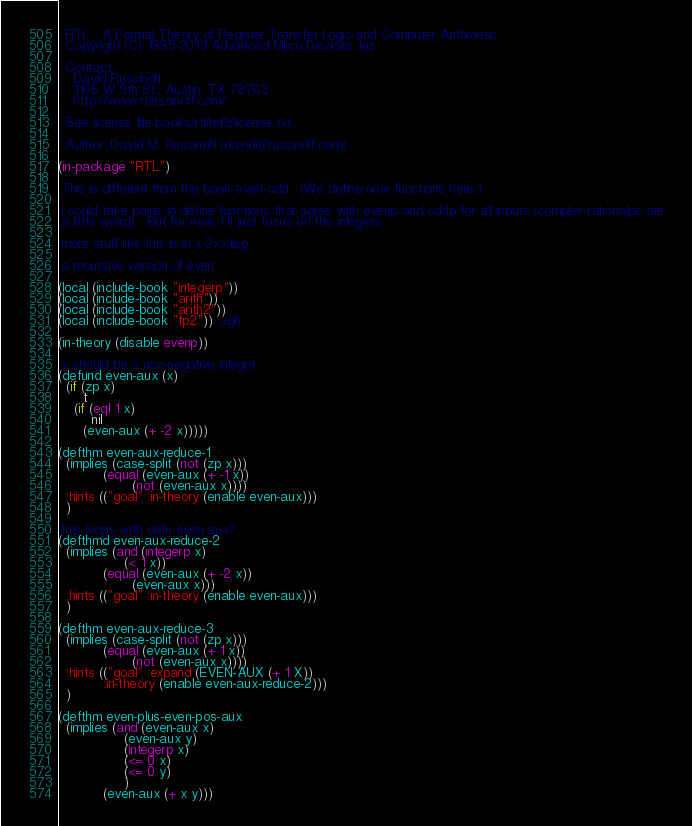Convert code to text. <code><loc_0><loc_0><loc_500><loc_500><_Lisp_>; RTL - A Formal Theory of Register-Transfer Logic and Computer Arithmetic
; Copyright (C) 1995-2013 Advanced Mirco Devices, Inc.
;
; Contact:
;   David Russinoff
;   1106 W 9th St., Austin, TX 78703
;   http://www.russsinoff.com/
;
; See license file books/rtl/rel9/license.txt.
;
; Author: David M. Russinoff (david@russinoff.com)

(in-package "RTL")

;This is different from the book even-odd.  (We define new functions here.)

;I could take pains to define functions that agree with evenp and oddp for all inputs (complex-rationalps are
;a little weird).  But for now, I'll just focus on the integers.

;more stuff like this is in x-2xx.lisp

;a recursive version of even

(local (include-book "integerp"))
(local (include-book "arith"))
(local (include-book "arith2"))
(local (include-book "fp2")) ;ugh

(in-theory (disable evenp))

;x should be a non-negative integer
(defund even-aux (x)
  (if (zp x)
      t
    (if (eql 1 x)
        nil
      (even-aux (+ -2 x)))))

(defthm even-aux-reduce-1
  (implies (case-split (not (zp x)))
           (equal (even-aux (+ -1 x))
                  (not (even-aux x))))
  :hints (("goal" :in-theory (enable even-aux)))
  )

;this loops with defn even-aux?
(defthmd even-aux-reduce-2
  (implies (and (integerp x)
                (< 1 x))
           (equal (even-aux (+ -2 x))
                  (even-aux x)))
  :hints (("goal" :in-theory (enable even-aux)))
  )

(defthm even-aux-reduce-3
  (implies (case-split (not (zp x)))
           (equal (even-aux (+ 1 x))
                  (not (even-aux x))))
  :hints (("goal" :expand (EVEN-AUX (+ 1 X))
           :in-theory (enable even-aux-reduce-2)))
  )

(defthm even-plus-even-pos-aux
  (implies (and (even-aux x)
                (even-aux y)
                (integerp x)
                (<= 0 x)
                (<= 0 y)
                )
           (even-aux (+ x y)))</code> 